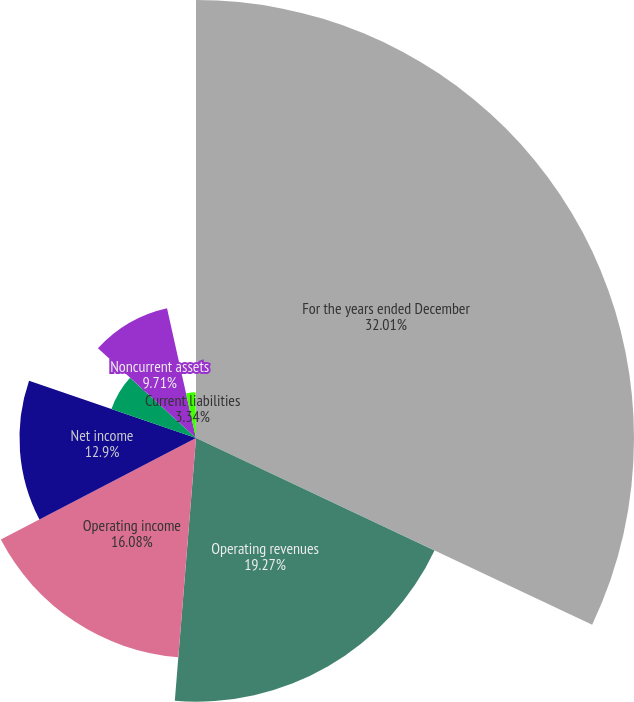Convert chart. <chart><loc_0><loc_0><loc_500><loc_500><pie_chart><fcel>For the years ended December<fcel>Operating revenues<fcel>Operating income<fcel>Net income<fcel>Current assets<fcel>Noncurrent assets<fcel>Current liabilities<fcel>Noncurrent liabilities<nl><fcel>32.01%<fcel>19.27%<fcel>16.08%<fcel>12.9%<fcel>6.53%<fcel>9.71%<fcel>3.34%<fcel>0.16%<nl></chart> 